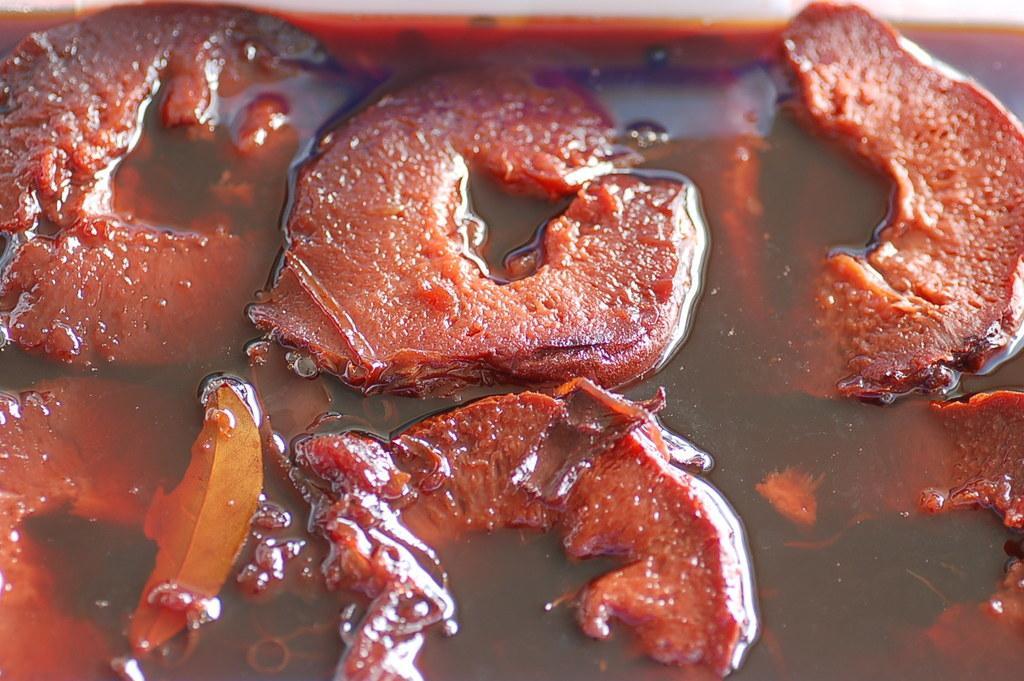How would you summarize this image in a sentence or two? In this image we can see a food item. 